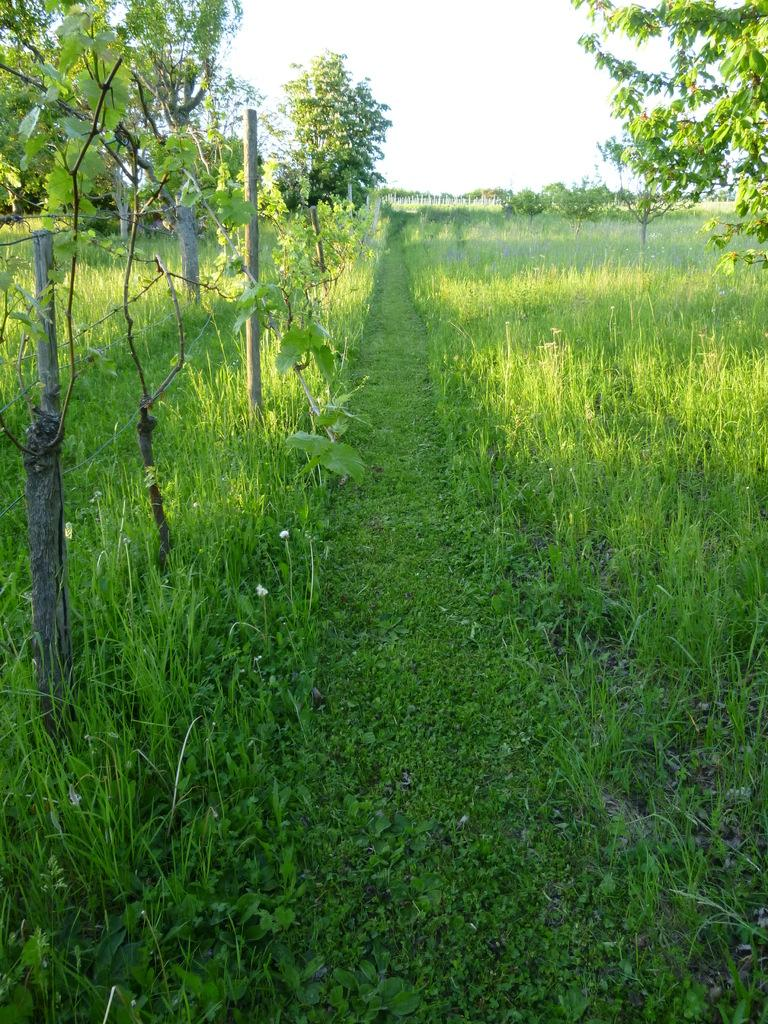What type of vegetation is present in the image? There is grass, plants, and trees in the image. Where are the trees located in relation to the land? The trees are on the land in the image. What can be seen on the left side of the image? There is a fence on the left side of the image. What is visible at the top of the image? The sky is visible at the top of the image. What is the title of the book that is being read by the person in the image? There is no person or book present in the image; it features grass, plants, trees, a fence, and the sky. 